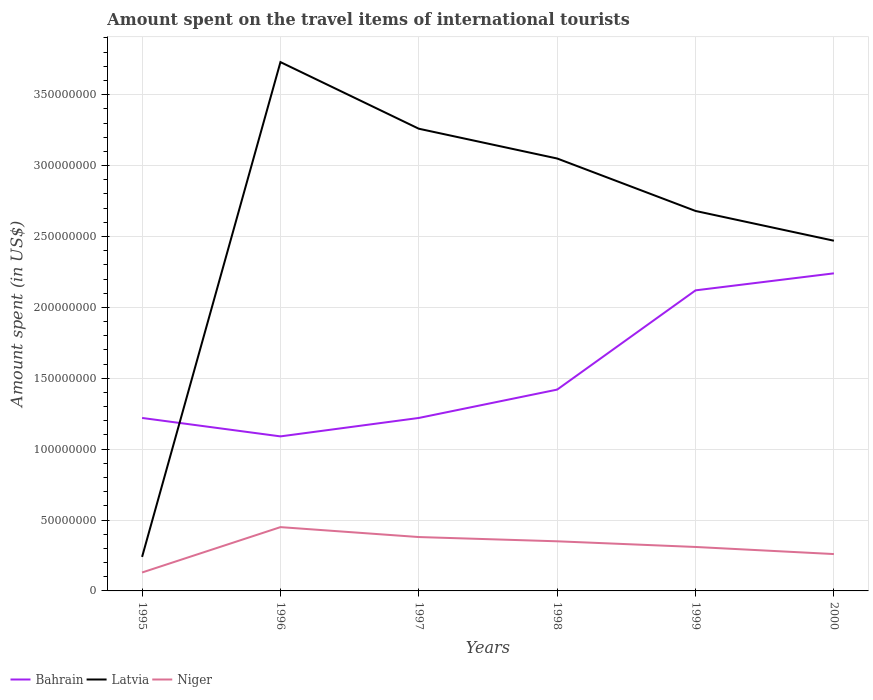Across all years, what is the maximum amount spent on the travel items of international tourists in Bahrain?
Ensure brevity in your answer.  1.09e+08. What is the total amount spent on the travel items of international tourists in Latvia in the graph?
Provide a succinct answer. -2.44e+08. What is the difference between the highest and the second highest amount spent on the travel items of international tourists in Niger?
Keep it short and to the point. 3.20e+07. What is the difference between the highest and the lowest amount spent on the travel items of international tourists in Latvia?
Keep it short and to the point. 4. How many lines are there?
Offer a very short reply. 3. Are the values on the major ticks of Y-axis written in scientific E-notation?
Ensure brevity in your answer.  No. How many legend labels are there?
Ensure brevity in your answer.  3. How are the legend labels stacked?
Offer a terse response. Horizontal. What is the title of the graph?
Offer a very short reply. Amount spent on the travel items of international tourists. What is the label or title of the Y-axis?
Make the answer very short. Amount spent (in US$). What is the Amount spent (in US$) of Bahrain in 1995?
Your response must be concise. 1.22e+08. What is the Amount spent (in US$) in Latvia in 1995?
Your answer should be compact. 2.40e+07. What is the Amount spent (in US$) in Niger in 1995?
Your answer should be very brief. 1.30e+07. What is the Amount spent (in US$) in Bahrain in 1996?
Offer a terse response. 1.09e+08. What is the Amount spent (in US$) in Latvia in 1996?
Your response must be concise. 3.73e+08. What is the Amount spent (in US$) of Niger in 1996?
Ensure brevity in your answer.  4.50e+07. What is the Amount spent (in US$) in Bahrain in 1997?
Offer a terse response. 1.22e+08. What is the Amount spent (in US$) in Latvia in 1997?
Keep it short and to the point. 3.26e+08. What is the Amount spent (in US$) in Niger in 1997?
Keep it short and to the point. 3.80e+07. What is the Amount spent (in US$) of Bahrain in 1998?
Make the answer very short. 1.42e+08. What is the Amount spent (in US$) in Latvia in 1998?
Offer a very short reply. 3.05e+08. What is the Amount spent (in US$) in Niger in 1998?
Your response must be concise. 3.50e+07. What is the Amount spent (in US$) of Bahrain in 1999?
Make the answer very short. 2.12e+08. What is the Amount spent (in US$) in Latvia in 1999?
Your answer should be very brief. 2.68e+08. What is the Amount spent (in US$) in Niger in 1999?
Provide a short and direct response. 3.10e+07. What is the Amount spent (in US$) of Bahrain in 2000?
Your answer should be very brief. 2.24e+08. What is the Amount spent (in US$) in Latvia in 2000?
Keep it short and to the point. 2.47e+08. What is the Amount spent (in US$) in Niger in 2000?
Offer a very short reply. 2.60e+07. Across all years, what is the maximum Amount spent (in US$) of Bahrain?
Make the answer very short. 2.24e+08. Across all years, what is the maximum Amount spent (in US$) in Latvia?
Provide a short and direct response. 3.73e+08. Across all years, what is the maximum Amount spent (in US$) of Niger?
Your answer should be compact. 4.50e+07. Across all years, what is the minimum Amount spent (in US$) in Bahrain?
Provide a succinct answer. 1.09e+08. Across all years, what is the minimum Amount spent (in US$) of Latvia?
Keep it short and to the point. 2.40e+07. Across all years, what is the minimum Amount spent (in US$) of Niger?
Give a very brief answer. 1.30e+07. What is the total Amount spent (in US$) of Bahrain in the graph?
Provide a succinct answer. 9.31e+08. What is the total Amount spent (in US$) of Latvia in the graph?
Provide a short and direct response. 1.54e+09. What is the total Amount spent (in US$) in Niger in the graph?
Provide a succinct answer. 1.88e+08. What is the difference between the Amount spent (in US$) of Bahrain in 1995 and that in 1996?
Keep it short and to the point. 1.30e+07. What is the difference between the Amount spent (in US$) of Latvia in 1995 and that in 1996?
Offer a terse response. -3.49e+08. What is the difference between the Amount spent (in US$) in Niger in 1995 and that in 1996?
Make the answer very short. -3.20e+07. What is the difference between the Amount spent (in US$) of Bahrain in 1995 and that in 1997?
Give a very brief answer. 0. What is the difference between the Amount spent (in US$) of Latvia in 1995 and that in 1997?
Make the answer very short. -3.02e+08. What is the difference between the Amount spent (in US$) of Niger in 1995 and that in 1997?
Your answer should be very brief. -2.50e+07. What is the difference between the Amount spent (in US$) in Bahrain in 1995 and that in 1998?
Your response must be concise. -2.00e+07. What is the difference between the Amount spent (in US$) in Latvia in 1995 and that in 1998?
Your response must be concise. -2.81e+08. What is the difference between the Amount spent (in US$) in Niger in 1995 and that in 1998?
Offer a terse response. -2.20e+07. What is the difference between the Amount spent (in US$) of Bahrain in 1995 and that in 1999?
Provide a short and direct response. -9.00e+07. What is the difference between the Amount spent (in US$) of Latvia in 1995 and that in 1999?
Your answer should be very brief. -2.44e+08. What is the difference between the Amount spent (in US$) in Niger in 1995 and that in 1999?
Provide a succinct answer. -1.80e+07. What is the difference between the Amount spent (in US$) of Bahrain in 1995 and that in 2000?
Ensure brevity in your answer.  -1.02e+08. What is the difference between the Amount spent (in US$) in Latvia in 1995 and that in 2000?
Offer a terse response. -2.23e+08. What is the difference between the Amount spent (in US$) in Niger in 1995 and that in 2000?
Give a very brief answer. -1.30e+07. What is the difference between the Amount spent (in US$) of Bahrain in 1996 and that in 1997?
Give a very brief answer. -1.30e+07. What is the difference between the Amount spent (in US$) of Latvia in 1996 and that in 1997?
Make the answer very short. 4.70e+07. What is the difference between the Amount spent (in US$) in Niger in 1996 and that in 1997?
Give a very brief answer. 7.00e+06. What is the difference between the Amount spent (in US$) in Bahrain in 1996 and that in 1998?
Give a very brief answer. -3.30e+07. What is the difference between the Amount spent (in US$) of Latvia in 1996 and that in 1998?
Offer a terse response. 6.80e+07. What is the difference between the Amount spent (in US$) in Bahrain in 1996 and that in 1999?
Keep it short and to the point. -1.03e+08. What is the difference between the Amount spent (in US$) of Latvia in 1996 and that in 1999?
Provide a succinct answer. 1.05e+08. What is the difference between the Amount spent (in US$) in Niger in 1996 and that in 1999?
Your answer should be very brief. 1.40e+07. What is the difference between the Amount spent (in US$) of Bahrain in 1996 and that in 2000?
Provide a succinct answer. -1.15e+08. What is the difference between the Amount spent (in US$) in Latvia in 1996 and that in 2000?
Give a very brief answer. 1.26e+08. What is the difference between the Amount spent (in US$) of Niger in 1996 and that in 2000?
Provide a succinct answer. 1.90e+07. What is the difference between the Amount spent (in US$) of Bahrain in 1997 and that in 1998?
Give a very brief answer. -2.00e+07. What is the difference between the Amount spent (in US$) of Latvia in 1997 and that in 1998?
Your answer should be very brief. 2.10e+07. What is the difference between the Amount spent (in US$) in Bahrain in 1997 and that in 1999?
Your response must be concise. -9.00e+07. What is the difference between the Amount spent (in US$) of Latvia in 1997 and that in 1999?
Give a very brief answer. 5.80e+07. What is the difference between the Amount spent (in US$) in Bahrain in 1997 and that in 2000?
Your response must be concise. -1.02e+08. What is the difference between the Amount spent (in US$) of Latvia in 1997 and that in 2000?
Offer a very short reply. 7.90e+07. What is the difference between the Amount spent (in US$) in Bahrain in 1998 and that in 1999?
Give a very brief answer. -7.00e+07. What is the difference between the Amount spent (in US$) of Latvia in 1998 and that in 1999?
Ensure brevity in your answer.  3.70e+07. What is the difference between the Amount spent (in US$) in Bahrain in 1998 and that in 2000?
Make the answer very short. -8.20e+07. What is the difference between the Amount spent (in US$) of Latvia in 1998 and that in 2000?
Offer a terse response. 5.80e+07. What is the difference between the Amount spent (in US$) in Niger in 1998 and that in 2000?
Provide a short and direct response. 9.00e+06. What is the difference between the Amount spent (in US$) of Bahrain in 1999 and that in 2000?
Your response must be concise. -1.20e+07. What is the difference between the Amount spent (in US$) in Latvia in 1999 and that in 2000?
Offer a very short reply. 2.10e+07. What is the difference between the Amount spent (in US$) in Bahrain in 1995 and the Amount spent (in US$) in Latvia in 1996?
Keep it short and to the point. -2.51e+08. What is the difference between the Amount spent (in US$) of Bahrain in 1995 and the Amount spent (in US$) of Niger in 1996?
Provide a succinct answer. 7.70e+07. What is the difference between the Amount spent (in US$) in Latvia in 1995 and the Amount spent (in US$) in Niger in 1996?
Keep it short and to the point. -2.10e+07. What is the difference between the Amount spent (in US$) of Bahrain in 1995 and the Amount spent (in US$) of Latvia in 1997?
Give a very brief answer. -2.04e+08. What is the difference between the Amount spent (in US$) in Bahrain in 1995 and the Amount spent (in US$) in Niger in 1997?
Your response must be concise. 8.40e+07. What is the difference between the Amount spent (in US$) of Latvia in 1995 and the Amount spent (in US$) of Niger in 1997?
Keep it short and to the point. -1.40e+07. What is the difference between the Amount spent (in US$) in Bahrain in 1995 and the Amount spent (in US$) in Latvia in 1998?
Your response must be concise. -1.83e+08. What is the difference between the Amount spent (in US$) of Bahrain in 1995 and the Amount spent (in US$) of Niger in 1998?
Make the answer very short. 8.70e+07. What is the difference between the Amount spent (in US$) in Latvia in 1995 and the Amount spent (in US$) in Niger in 1998?
Make the answer very short. -1.10e+07. What is the difference between the Amount spent (in US$) of Bahrain in 1995 and the Amount spent (in US$) of Latvia in 1999?
Keep it short and to the point. -1.46e+08. What is the difference between the Amount spent (in US$) in Bahrain in 1995 and the Amount spent (in US$) in Niger in 1999?
Your answer should be very brief. 9.10e+07. What is the difference between the Amount spent (in US$) in Latvia in 1995 and the Amount spent (in US$) in Niger in 1999?
Provide a succinct answer. -7.00e+06. What is the difference between the Amount spent (in US$) of Bahrain in 1995 and the Amount spent (in US$) of Latvia in 2000?
Your answer should be very brief. -1.25e+08. What is the difference between the Amount spent (in US$) in Bahrain in 1995 and the Amount spent (in US$) in Niger in 2000?
Your answer should be compact. 9.60e+07. What is the difference between the Amount spent (in US$) in Bahrain in 1996 and the Amount spent (in US$) in Latvia in 1997?
Your answer should be compact. -2.17e+08. What is the difference between the Amount spent (in US$) of Bahrain in 1996 and the Amount spent (in US$) of Niger in 1997?
Offer a very short reply. 7.10e+07. What is the difference between the Amount spent (in US$) of Latvia in 1996 and the Amount spent (in US$) of Niger in 1997?
Offer a terse response. 3.35e+08. What is the difference between the Amount spent (in US$) of Bahrain in 1996 and the Amount spent (in US$) of Latvia in 1998?
Your response must be concise. -1.96e+08. What is the difference between the Amount spent (in US$) in Bahrain in 1996 and the Amount spent (in US$) in Niger in 1998?
Keep it short and to the point. 7.40e+07. What is the difference between the Amount spent (in US$) in Latvia in 1996 and the Amount spent (in US$) in Niger in 1998?
Keep it short and to the point. 3.38e+08. What is the difference between the Amount spent (in US$) of Bahrain in 1996 and the Amount spent (in US$) of Latvia in 1999?
Your response must be concise. -1.59e+08. What is the difference between the Amount spent (in US$) in Bahrain in 1996 and the Amount spent (in US$) in Niger in 1999?
Keep it short and to the point. 7.80e+07. What is the difference between the Amount spent (in US$) in Latvia in 1996 and the Amount spent (in US$) in Niger in 1999?
Offer a terse response. 3.42e+08. What is the difference between the Amount spent (in US$) of Bahrain in 1996 and the Amount spent (in US$) of Latvia in 2000?
Give a very brief answer. -1.38e+08. What is the difference between the Amount spent (in US$) of Bahrain in 1996 and the Amount spent (in US$) of Niger in 2000?
Your response must be concise. 8.30e+07. What is the difference between the Amount spent (in US$) in Latvia in 1996 and the Amount spent (in US$) in Niger in 2000?
Keep it short and to the point. 3.47e+08. What is the difference between the Amount spent (in US$) of Bahrain in 1997 and the Amount spent (in US$) of Latvia in 1998?
Ensure brevity in your answer.  -1.83e+08. What is the difference between the Amount spent (in US$) in Bahrain in 1997 and the Amount spent (in US$) in Niger in 1998?
Your answer should be very brief. 8.70e+07. What is the difference between the Amount spent (in US$) of Latvia in 1997 and the Amount spent (in US$) of Niger in 1998?
Your response must be concise. 2.91e+08. What is the difference between the Amount spent (in US$) in Bahrain in 1997 and the Amount spent (in US$) in Latvia in 1999?
Ensure brevity in your answer.  -1.46e+08. What is the difference between the Amount spent (in US$) of Bahrain in 1997 and the Amount spent (in US$) of Niger in 1999?
Keep it short and to the point. 9.10e+07. What is the difference between the Amount spent (in US$) of Latvia in 1997 and the Amount spent (in US$) of Niger in 1999?
Provide a short and direct response. 2.95e+08. What is the difference between the Amount spent (in US$) in Bahrain in 1997 and the Amount spent (in US$) in Latvia in 2000?
Offer a very short reply. -1.25e+08. What is the difference between the Amount spent (in US$) of Bahrain in 1997 and the Amount spent (in US$) of Niger in 2000?
Your answer should be very brief. 9.60e+07. What is the difference between the Amount spent (in US$) of Latvia in 1997 and the Amount spent (in US$) of Niger in 2000?
Give a very brief answer. 3.00e+08. What is the difference between the Amount spent (in US$) in Bahrain in 1998 and the Amount spent (in US$) in Latvia in 1999?
Provide a succinct answer. -1.26e+08. What is the difference between the Amount spent (in US$) of Bahrain in 1998 and the Amount spent (in US$) of Niger in 1999?
Offer a terse response. 1.11e+08. What is the difference between the Amount spent (in US$) in Latvia in 1998 and the Amount spent (in US$) in Niger in 1999?
Offer a very short reply. 2.74e+08. What is the difference between the Amount spent (in US$) in Bahrain in 1998 and the Amount spent (in US$) in Latvia in 2000?
Offer a very short reply. -1.05e+08. What is the difference between the Amount spent (in US$) in Bahrain in 1998 and the Amount spent (in US$) in Niger in 2000?
Provide a succinct answer. 1.16e+08. What is the difference between the Amount spent (in US$) in Latvia in 1998 and the Amount spent (in US$) in Niger in 2000?
Your answer should be compact. 2.79e+08. What is the difference between the Amount spent (in US$) of Bahrain in 1999 and the Amount spent (in US$) of Latvia in 2000?
Ensure brevity in your answer.  -3.50e+07. What is the difference between the Amount spent (in US$) in Bahrain in 1999 and the Amount spent (in US$) in Niger in 2000?
Provide a short and direct response. 1.86e+08. What is the difference between the Amount spent (in US$) in Latvia in 1999 and the Amount spent (in US$) in Niger in 2000?
Ensure brevity in your answer.  2.42e+08. What is the average Amount spent (in US$) in Bahrain per year?
Provide a short and direct response. 1.55e+08. What is the average Amount spent (in US$) in Latvia per year?
Offer a terse response. 2.57e+08. What is the average Amount spent (in US$) in Niger per year?
Your answer should be compact. 3.13e+07. In the year 1995, what is the difference between the Amount spent (in US$) in Bahrain and Amount spent (in US$) in Latvia?
Your response must be concise. 9.80e+07. In the year 1995, what is the difference between the Amount spent (in US$) of Bahrain and Amount spent (in US$) of Niger?
Give a very brief answer. 1.09e+08. In the year 1995, what is the difference between the Amount spent (in US$) of Latvia and Amount spent (in US$) of Niger?
Provide a short and direct response. 1.10e+07. In the year 1996, what is the difference between the Amount spent (in US$) in Bahrain and Amount spent (in US$) in Latvia?
Your answer should be very brief. -2.64e+08. In the year 1996, what is the difference between the Amount spent (in US$) in Bahrain and Amount spent (in US$) in Niger?
Make the answer very short. 6.40e+07. In the year 1996, what is the difference between the Amount spent (in US$) of Latvia and Amount spent (in US$) of Niger?
Give a very brief answer. 3.28e+08. In the year 1997, what is the difference between the Amount spent (in US$) of Bahrain and Amount spent (in US$) of Latvia?
Keep it short and to the point. -2.04e+08. In the year 1997, what is the difference between the Amount spent (in US$) of Bahrain and Amount spent (in US$) of Niger?
Your response must be concise. 8.40e+07. In the year 1997, what is the difference between the Amount spent (in US$) in Latvia and Amount spent (in US$) in Niger?
Make the answer very short. 2.88e+08. In the year 1998, what is the difference between the Amount spent (in US$) of Bahrain and Amount spent (in US$) of Latvia?
Make the answer very short. -1.63e+08. In the year 1998, what is the difference between the Amount spent (in US$) of Bahrain and Amount spent (in US$) of Niger?
Offer a very short reply. 1.07e+08. In the year 1998, what is the difference between the Amount spent (in US$) of Latvia and Amount spent (in US$) of Niger?
Offer a terse response. 2.70e+08. In the year 1999, what is the difference between the Amount spent (in US$) of Bahrain and Amount spent (in US$) of Latvia?
Offer a very short reply. -5.60e+07. In the year 1999, what is the difference between the Amount spent (in US$) in Bahrain and Amount spent (in US$) in Niger?
Your answer should be very brief. 1.81e+08. In the year 1999, what is the difference between the Amount spent (in US$) in Latvia and Amount spent (in US$) in Niger?
Your answer should be compact. 2.37e+08. In the year 2000, what is the difference between the Amount spent (in US$) in Bahrain and Amount spent (in US$) in Latvia?
Offer a terse response. -2.30e+07. In the year 2000, what is the difference between the Amount spent (in US$) of Bahrain and Amount spent (in US$) of Niger?
Offer a very short reply. 1.98e+08. In the year 2000, what is the difference between the Amount spent (in US$) in Latvia and Amount spent (in US$) in Niger?
Your answer should be very brief. 2.21e+08. What is the ratio of the Amount spent (in US$) of Bahrain in 1995 to that in 1996?
Provide a succinct answer. 1.12. What is the ratio of the Amount spent (in US$) in Latvia in 1995 to that in 1996?
Ensure brevity in your answer.  0.06. What is the ratio of the Amount spent (in US$) of Niger in 1995 to that in 1996?
Offer a very short reply. 0.29. What is the ratio of the Amount spent (in US$) in Bahrain in 1995 to that in 1997?
Make the answer very short. 1. What is the ratio of the Amount spent (in US$) of Latvia in 1995 to that in 1997?
Keep it short and to the point. 0.07. What is the ratio of the Amount spent (in US$) of Niger in 1995 to that in 1997?
Keep it short and to the point. 0.34. What is the ratio of the Amount spent (in US$) in Bahrain in 1995 to that in 1998?
Your response must be concise. 0.86. What is the ratio of the Amount spent (in US$) of Latvia in 1995 to that in 1998?
Offer a very short reply. 0.08. What is the ratio of the Amount spent (in US$) of Niger in 1995 to that in 1998?
Keep it short and to the point. 0.37. What is the ratio of the Amount spent (in US$) in Bahrain in 1995 to that in 1999?
Make the answer very short. 0.58. What is the ratio of the Amount spent (in US$) of Latvia in 1995 to that in 1999?
Ensure brevity in your answer.  0.09. What is the ratio of the Amount spent (in US$) of Niger in 1995 to that in 1999?
Make the answer very short. 0.42. What is the ratio of the Amount spent (in US$) of Bahrain in 1995 to that in 2000?
Keep it short and to the point. 0.54. What is the ratio of the Amount spent (in US$) of Latvia in 1995 to that in 2000?
Offer a very short reply. 0.1. What is the ratio of the Amount spent (in US$) of Bahrain in 1996 to that in 1997?
Ensure brevity in your answer.  0.89. What is the ratio of the Amount spent (in US$) in Latvia in 1996 to that in 1997?
Offer a very short reply. 1.14. What is the ratio of the Amount spent (in US$) in Niger in 1996 to that in 1997?
Provide a short and direct response. 1.18. What is the ratio of the Amount spent (in US$) in Bahrain in 1996 to that in 1998?
Offer a terse response. 0.77. What is the ratio of the Amount spent (in US$) in Latvia in 1996 to that in 1998?
Make the answer very short. 1.22. What is the ratio of the Amount spent (in US$) in Bahrain in 1996 to that in 1999?
Provide a succinct answer. 0.51. What is the ratio of the Amount spent (in US$) of Latvia in 1996 to that in 1999?
Your answer should be compact. 1.39. What is the ratio of the Amount spent (in US$) of Niger in 1996 to that in 1999?
Your answer should be compact. 1.45. What is the ratio of the Amount spent (in US$) of Bahrain in 1996 to that in 2000?
Provide a succinct answer. 0.49. What is the ratio of the Amount spent (in US$) in Latvia in 1996 to that in 2000?
Your answer should be compact. 1.51. What is the ratio of the Amount spent (in US$) of Niger in 1996 to that in 2000?
Your answer should be very brief. 1.73. What is the ratio of the Amount spent (in US$) of Bahrain in 1997 to that in 1998?
Ensure brevity in your answer.  0.86. What is the ratio of the Amount spent (in US$) of Latvia in 1997 to that in 1998?
Your response must be concise. 1.07. What is the ratio of the Amount spent (in US$) in Niger in 1997 to that in 1998?
Make the answer very short. 1.09. What is the ratio of the Amount spent (in US$) of Bahrain in 1997 to that in 1999?
Your answer should be very brief. 0.58. What is the ratio of the Amount spent (in US$) of Latvia in 1997 to that in 1999?
Give a very brief answer. 1.22. What is the ratio of the Amount spent (in US$) in Niger in 1997 to that in 1999?
Your answer should be compact. 1.23. What is the ratio of the Amount spent (in US$) in Bahrain in 1997 to that in 2000?
Your answer should be compact. 0.54. What is the ratio of the Amount spent (in US$) of Latvia in 1997 to that in 2000?
Your answer should be compact. 1.32. What is the ratio of the Amount spent (in US$) of Niger in 1997 to that in 2000?
Your answer should be compact. 1.46. What is the ratio of the Amount spent (in US$) of Bahrain in 1998 to that in 1999?
Ensure brevity in your answer.  0.67. What is the ratio of the Amount spent (in US$) of Latvia in 1998 to that in 1999?
Your answer should be very brief. 1.14. What is the ratio of the Amount spent (in US$) in Niger in 1998 to that in 1999?
Your response must be concise. 1.13. What is the ratio of the Amount spent (in US$) in Bahrain in 1998 to that in 2000?
Your answer should be very brief. 0.63. What is the ratio of the Amount spent (in US$) of Latvia in 1998 to that in 2000?
Your answer should be compact. 1.23. What is the ratio of the Amount spent (in US$) of Niger in 1998 to that in 2000?
Your answer should be compact. 1.35. What is the ratio of the Amount spent (in US$) in Bahrain in 1999 to that in 2000?
Offer a terse response. 0.95. What is the ratio of the Amount spent (in US$) of Latvia in 1999 to that in 2000?
Offer a terse response. 1.08. What is the ratio of the Amount spent (in US$) of Niger in 1999 to that in 2000?
Provide a succinct answer. 1.19. What is the difference between the highest and the second highest Amount spent (in US$) in Bahrain?
Provide a short and direct response. 1.20e+07. What is the difference between the highest and the second highest Amount spent (in US$) of Latvia?
Provide a short and direct response. 4.70e+07. What is the difference between the highest and the lowest Amount spent (in US$) of Bahrain?
Keep it short and to the point. 1.15e+08. What is the difference between the highest and the lowest Amount spent (in US$) in Latvia?
Provide a short and direct response. 3.49e+08. What is the difference between the highest and the lowest Amount spent (in US$) in Niger?
Provide a short and direct response. 3.20e+07. 